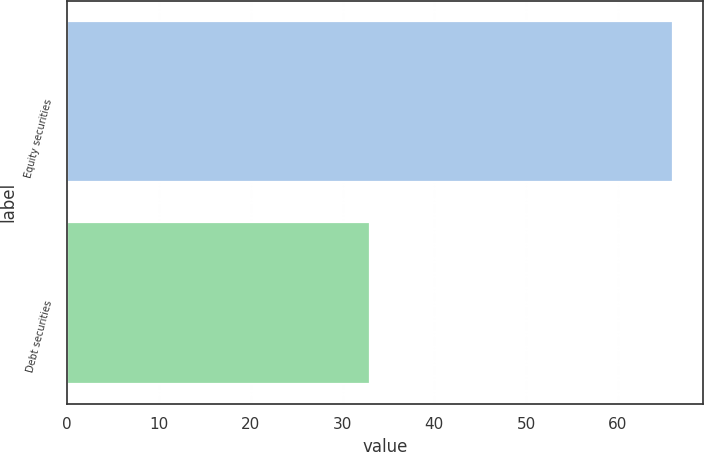Convert chart. <chart><loc_0><loc_0><loc_500><loc_500><bar_chart><fcel>Equity securities<fcel>Debt securities<nl><fcel>66<fcel>33<nl></chart> 